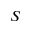Convert formula to latex. <formula><loc_0><loc_0><loc_500><loc_500>S</formula> 